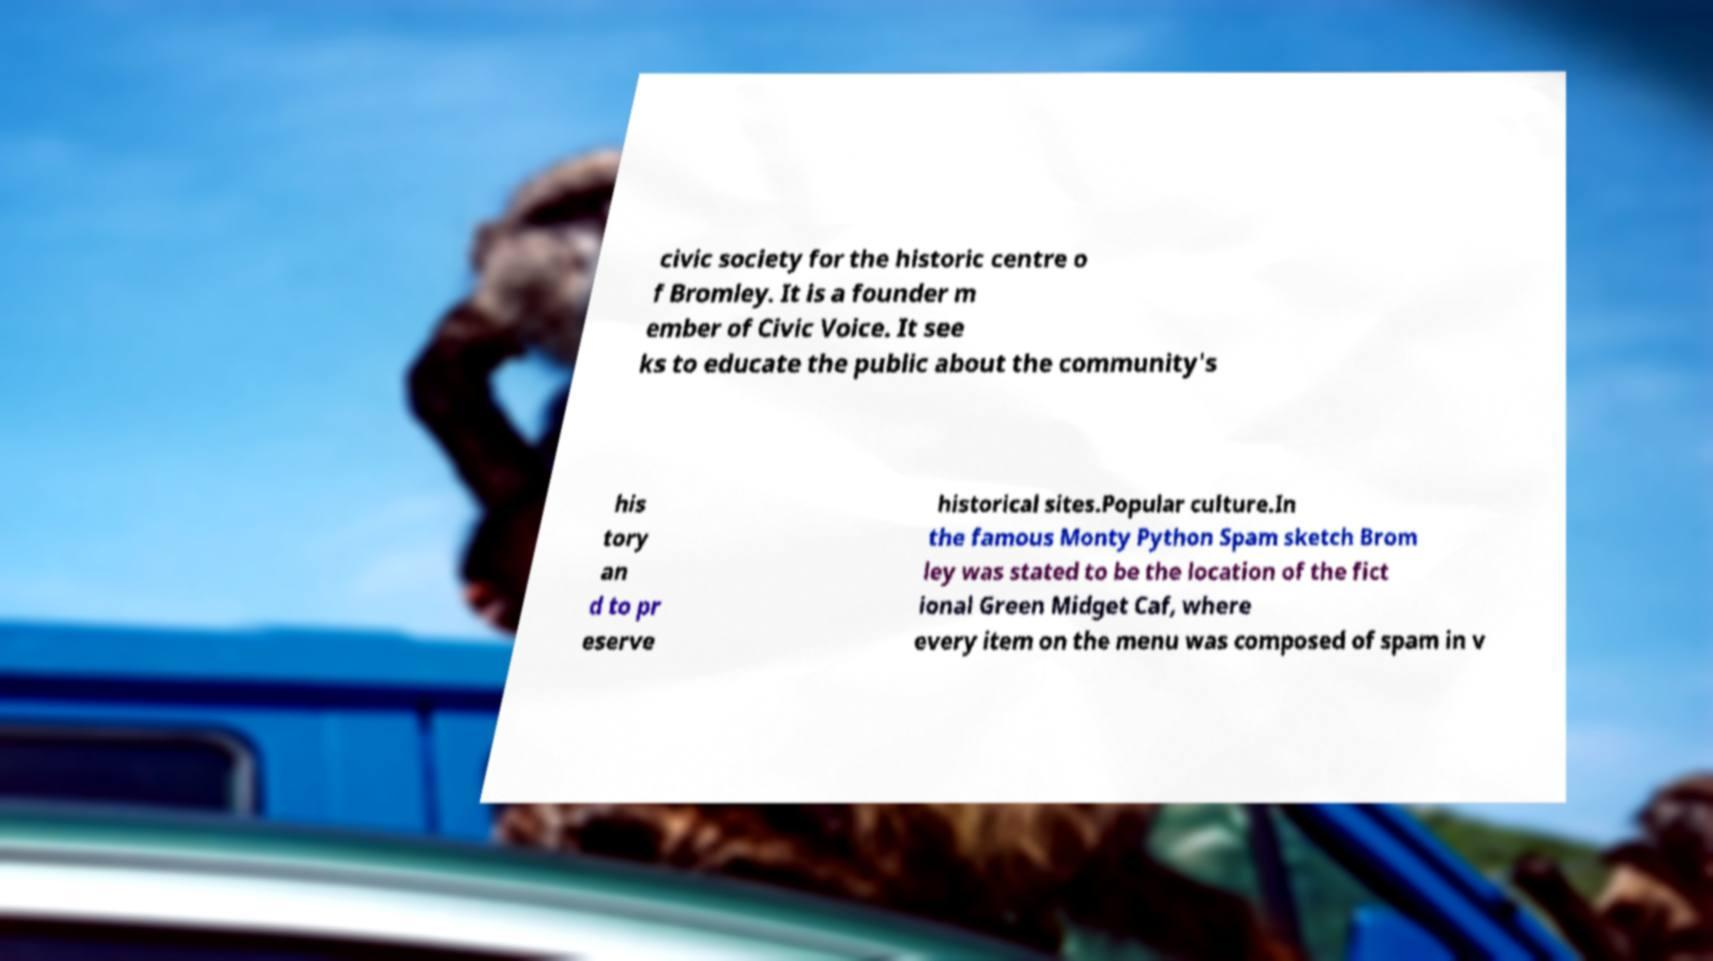Can you read and provide the text displayed in the image?This photo seems to have some interesting text. Can you extract and type it out for me? civic society for the historic centre o f Bromley. It is a founder m ember of Civic Voice. It see ks to educate the public about the community's his tory an d to pr eserve historical sites.Popular culture.In the famous Monty Python Spam sketch Brom ley was stated to be the location of the fict ional Green Midget Caf, where every item on the menu was composed of spam in v 